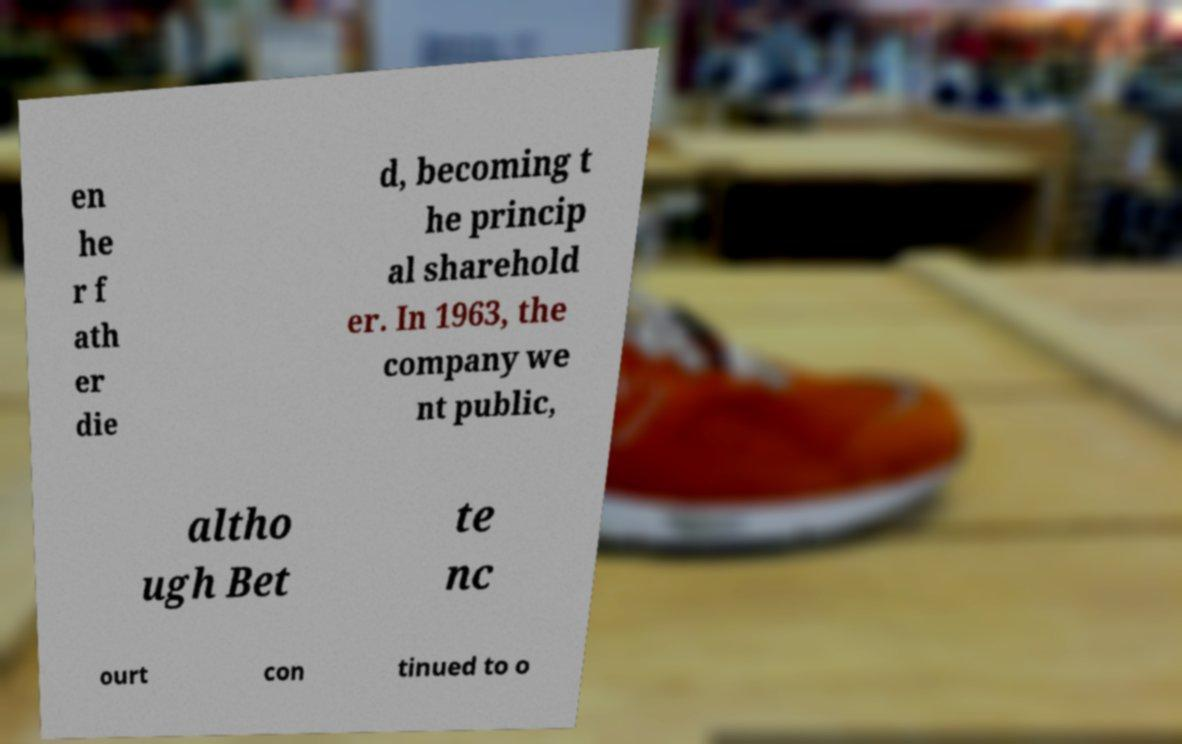For documentation purposes, I need the text within this image transcribed. Could you provide that? en he r f ath er die d, becoming t he princip al sharehold er. In 1963, the company we nt public, altho ugh Bet te nc ourt con tinued to o 